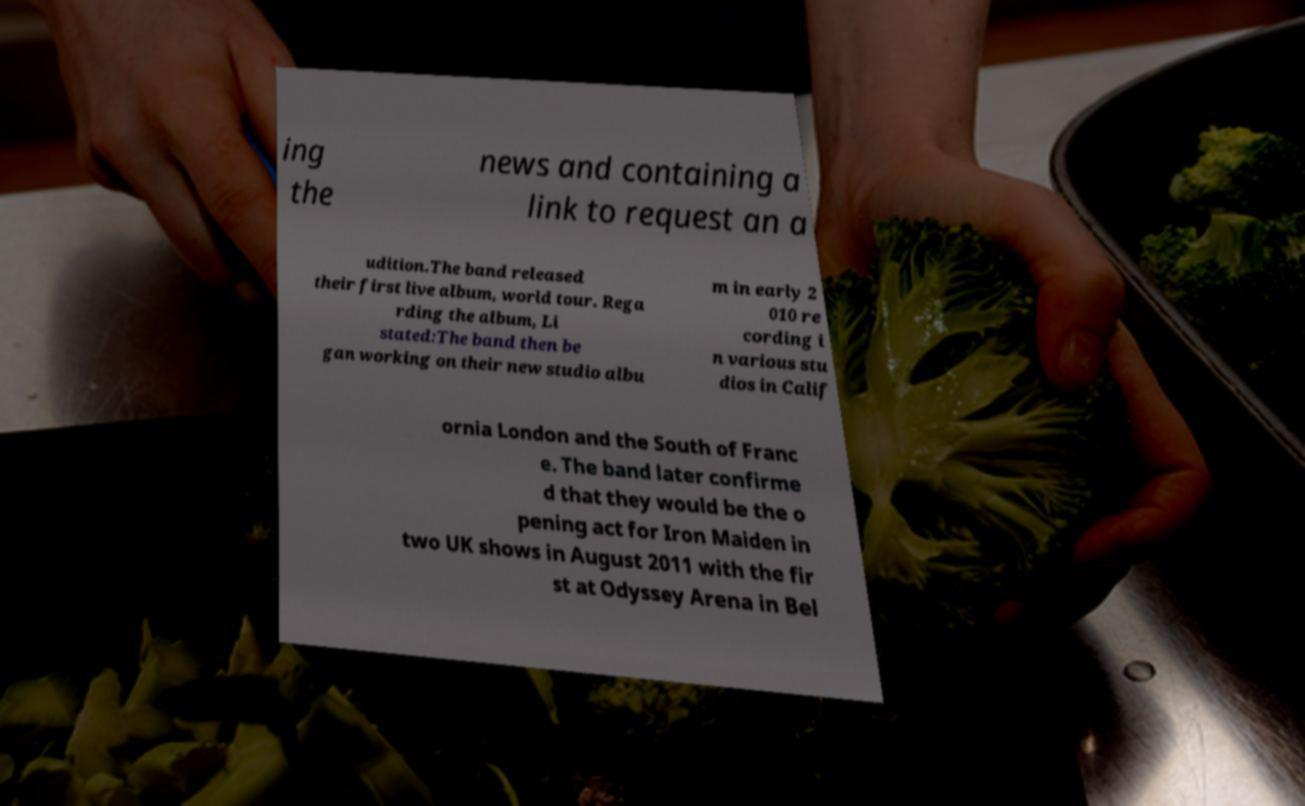Can you accurately transcribe the text from the provided image for me? ing the news and containing a link to request an a udition.The band released their first live album, world tour. Rega rding the album, Li stated:The band then be gan working on their new studio albu m in early 2 010 re cording i n various stu dios in Calif ornia London and the South of Franc e. The band later confirme d that they would be the o pening act for Iron Maiden in two UK shows in August 2011 with the fir st at Odyssey Arena in Bel 